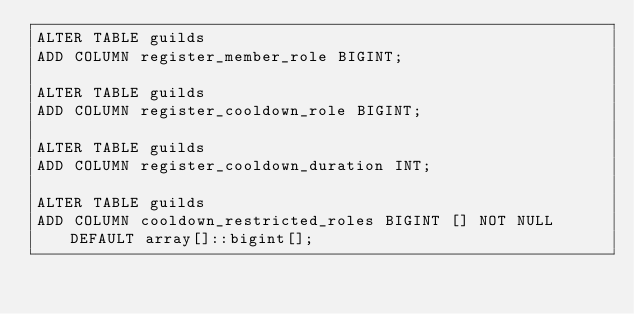Convert code to text. <code><loc_0><loc_0><loc_500><loc_500><_SQL_>ALTER TABLE guilds
ADD COLUMN register_member_role BIGINT;

ALTER TABLE guilds
ADD COLUMN register_cooldown_role BIGINT;

ALTER TABLE guilds
ADD COLUMN register_cooldown_duration INT;

ALTER TABLE guilds
ADD COLUMN cooldown_restricted_roles BIGINT [] NOT NULL DEFAULT array[]::bigint[];</code> 